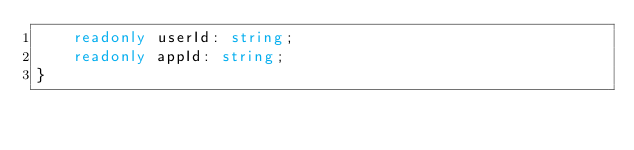Convert code to text. <code><loc_0><loc_0><loc_500><loc_500><_TypeScript_>    readonly userId: string;
    readonly appId: string;
}</code> 